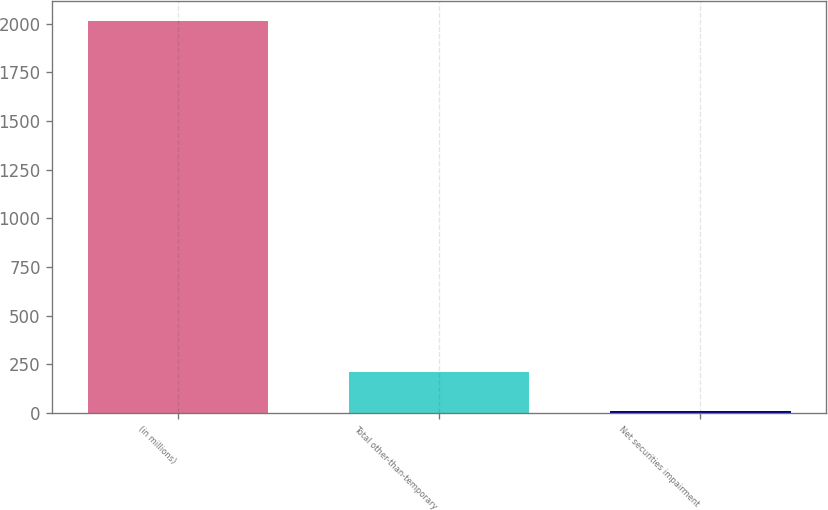Convert chart. <chart><loc_0><loc_0><loc_500><loc_500><bar_chart><fcel>(in millions)<fcel>Total other-than-temporary<fcel>Net securities impairment<nl><fcel>2015<fcel>207.8<fcel>7<nl></chart> 